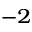<formula> <loc_0><loc_0><loc_500><loc_500>^ { - 2 }</formula> 